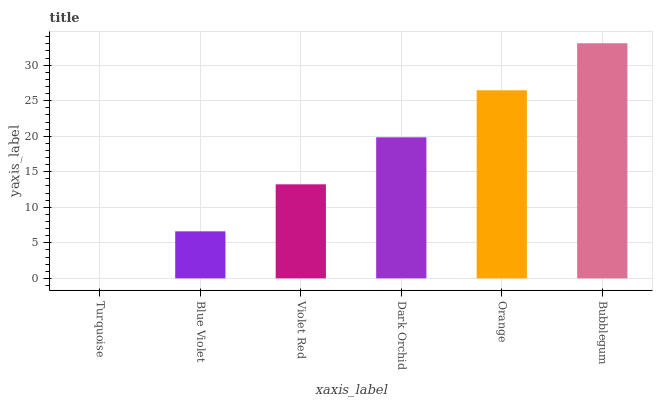Is Turquoise the minimum?
Answer yes or no. Yes. Is Bubblegum the maximum?
Answer yes or no. Yes. Is Blue Violet the minimum?
Answer yes or no. No. Is Blue Violet the maximum?
Answer yes or no. No. Is Blue Violet greater than Turquoise?
Answer yes or no. Yes. Is Turquoise less than Blue Violet?
Answer yes or no. Yes. Is Turquoise greater than Blue Violet?
Answer yes or no. No. Is Blue Violet less than Turquoise?
Answer yes or no. No. Is Dark Orchid the high median?
Answer yes or no. Yes. Is Violet Red the low median?
Answer yes or no. Yes. Is Blue Violet the high median?
Answer yes or no. No. Is Bubblegum the low median?
Answer yes or no. No. 